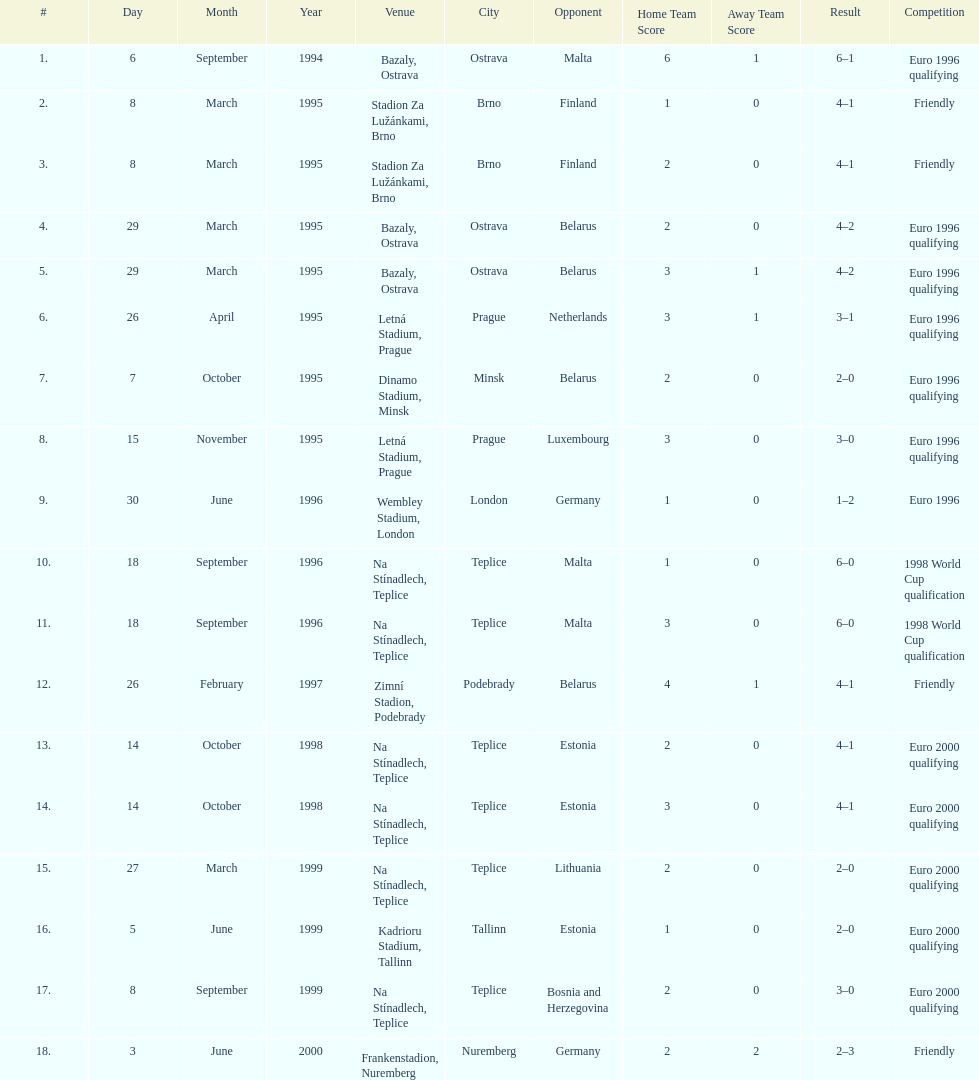Could you parse the entire table? {'header': ['#', 'Day', 'Month', 'Year', 'Venue', 'City', 'Opponent', 'Home Team Score', 'Away Team Score', 'Result', 'Competition'], 'rows': [['1.', '6', 'September', '1994', 'Bazaly, Ostrava', 'Ostrava', 'Malta', '6', '1', '6–1', 'Euro 1996 qualifying'], ['2.', '8', 'March', '1995', 'Stadion Za Lužánkami, Brno', 'Brno', 'Finland', '1', '0', '4–1', 'Friendly'], ['3.', '8', 'March', '1995', 'Stadion Za Lužánkami, Brno', 'Brno', 'Finland', '2', '0', '4–1', 'Friendly'], ['4.', '29', 'March', '1995', 'Bazaly, Ostrava', 'Ostrava', 'Belarus', '2', '0', '4–2', 'Euro 1996 qualifying'], ['5.', '29', 'March', '1995', 'Bazaly, Ostrava', 'Ostrava', 'Belarus', '3', '1', '4–2', 'Euro 1996 qualifying'], ['6.', '26', 'April', '1995', 'Letná Stadium, Prague', 'Prague', 'Netherlands', '3', '1', '3–1', 'Euro 1996 qualifying'], ['7.', '7', 'October', '1995', 'Dinamo Stadium, Minsk', 'Minsk', 'Belarus', '2', '0', '2–0', 'Euro 1996 qualifying'], ['8.', '15', 'November', '1995', 'Letná Stadium, Prague', 'Prague', 'Luxembourg', '3', '0', '3–0', 'Euro 1996 qualifying'], ['9.', '30', 'June', '1996', 'Wembley Stadium, London', 'London', 'Germany', '1', '0', '1–2', 'Euro 1996'], ['10.', '18', 'September', '1996', 'Na Stínadlech, Teplice', 'Teplice', 'Malta', '1', '0', '6–0', '1998 World Cup qualification'], ['11.', '18', 'September', '1996', 'Na Stínadlech, Teplice', 'Teplice', 'Malta', '3', '0', '6–0', '1998 World Cup qualification'], ['12.', '26', 'February', '1997', 'Zimní Stadion, Podebrady', 'Podebrady', 'Belarus', '4', '1', '4–1', 'Friendly'], ['13.', '14', 'October', '1998', 'Na Stínadlech, Teplice', 'Teplice', 'Estonia', '2', '0', '4–1', 'Euro 2000 qualifying'], ['14.', '14', 'October', '1998', 'Na Stínadlech, Teplice', 'Teplice', 'Estonia', '3', '0', '4–1', 'Euro 2000 qualifying'], ['15.', '27', 'March', '1999', 'Na Stínadlech, Teplice', 'Teplice', 'Lithuania', '2', '0', '2–0', 'Euro 2000 qualifying'], ['16.', '5', 'June', '1999', 'Kadrioru Stadium, Tallinn', 'Tallinn', 'Estonia', '1', '0', '2–0', 'Euro 2000 qualifying'], ['17.', '8', 'September', '1999', 'Na Stínadlech, Teplice', 'Teplice', 'Bosnia and Herzegovina', '2', '0', '3–0', 'Euro 2000 qualifying'], ['18.', '3', 'June', '2000', 'Frankenstadion, Nuremberg', 'Nuremberg', 'Germany', '2', '2', '2–3', 'Friendly']]} How many games took place in ostrava? 2. 